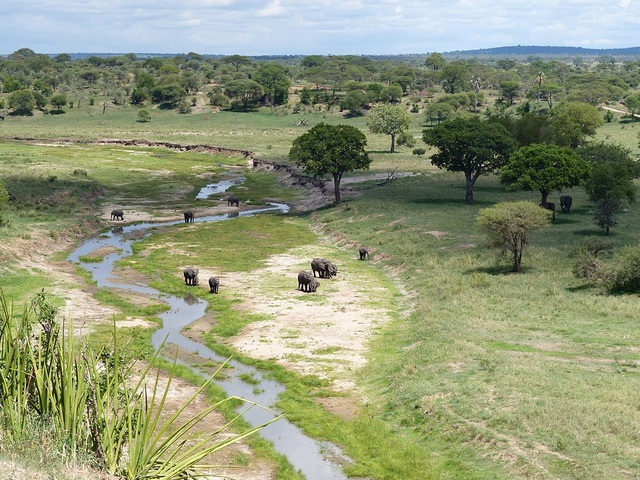Describe the objects in this image and their specific colors. I can see elephant in lightblue, black, gray, and darkgray tones, elephant in lightblue, black, gray, and darkgray tones, elephant in lightblue, black, gray, and darkgray tones, elephant in lightblue, black, and gray tones, and elephant in lightblue, black, gray, and darkgray tones in this image. 